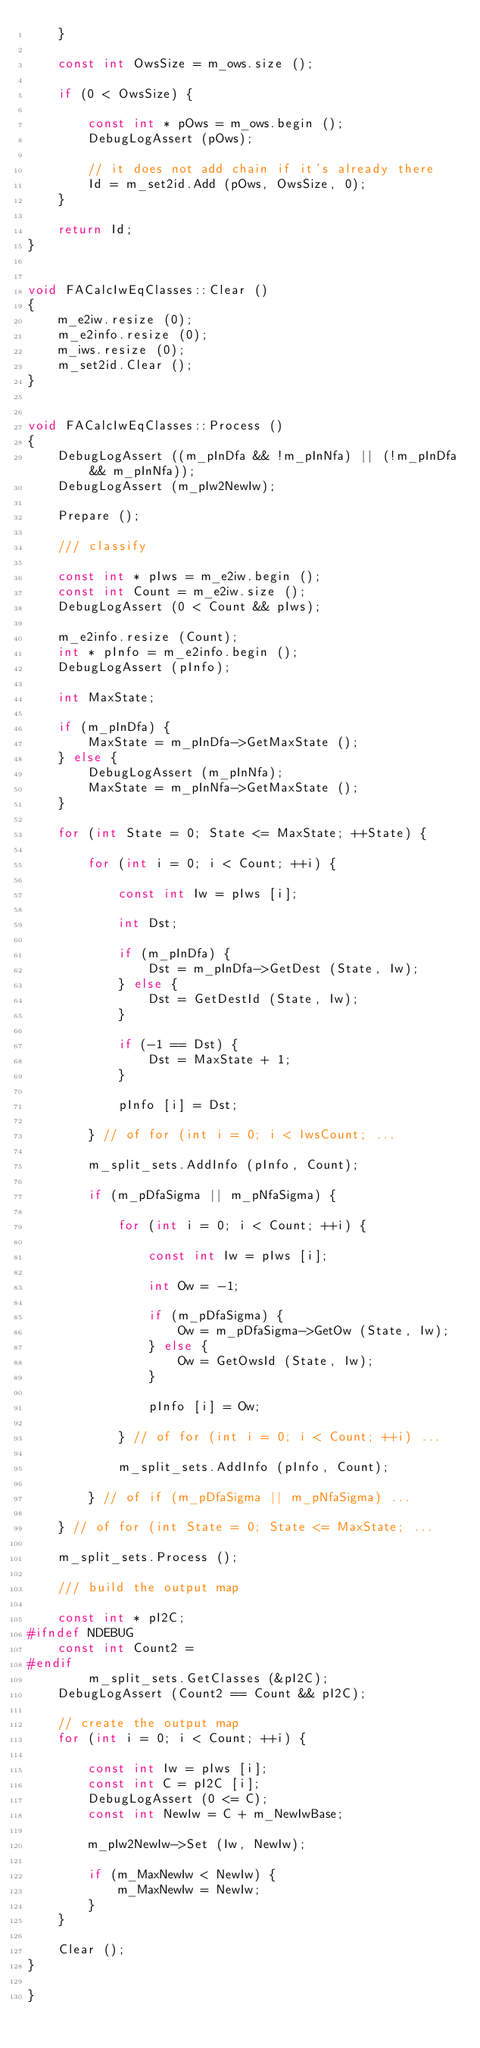<code> <loc_0><loc_0><loc_500><loc_500><_C++_>    }

    const int OwsSize = m_ows.size ();

    if (0 < OwsSize) {

        const int * pOws = m_ows.begin ();
        DebugLogAssert (pOws);

        // it does not add chain if it's already there
        Id = m_set2id.Add (pOws, OwsSize, 0);
    }

    return Id;
}


void FACalcIwEqClasses::Clear ()
{
    m_e2iw.resize (0);
    m_e2info.resize (0);
    m_iws.resize (0);
    m_set2id.Clear ();
}


void FACalcIwEqClasses::Process ()
{
    DebugLogAssert ((m_pInDfa && !m_pInNfa) || (!m_pInDfa && m_pInNfa));
    DebugLogAssert (m_pIw2NewIw);

    Prepare ();

    /// classify

    const int * pIws = m_e2iw.begin ();
    const int Count = m_e2iw.size ();
    DebugLogAssert (0 < Count && pIws);

    m_e2info.resize (Count);
    int * pInfo = m_e2info.begin ();
    DebugLogAssert (pInfo);

    int MaxState;
    
    if (m_pInDfa) {
        MaxState = m_pInDfa->GetMaxState ();
    } else {
        DebugLogAssert (m_pInNfa);
        MaxState = m_pInNfa->GetMaxState ();
    }

    for (int State = 0; State <= MaxState; ++State) {

        for (int i = 0; i < Count; ++i) {

            const int Iw = pIws [i];

            int Dst;

            if (m_pInDfa) {
                Dst = m_pInDfa->GetDest (State, Iw);
            } else {
                Dst = GetDestId (State, Iw);
            }

            if (-1 == Dst) {
                Dst = MaxState + 1;
            }

            pInfo [i] = Dst;

        } // of for (int i = 0; i < IwsCount; ...

        m_split_sets.AddInfo (pInfo, Count);

        if (m_pDfaSigma || m_pNfaSigma) {

            for (int i = 0; i < Count; ++i) {

                const int Iw = pIws [i];

                int Ow = -1;

                if (m_pDfaSigma) {
                    Ow = m_pDfaSigma->GetOw (State, Iw);
                } else {
                    Ow = GetOwsId (State, Iw);
                }

                pInfo [i] = Ow;

            } // of for (int i = 0; i < Count; ++i) ...

            m_split_sets.AddInfo (pInfo, Count);

        } // of if (m_pDfaSigma || m_pNfaSigma) ...

    } // of for (int State = 0; State <= MaxState; ...

    m_split_sets.Process ();

    /// build the output map

    const int * pI2C;
#ifndef NDEBUG
    const int Count2 = 
#endif
        m_split_sets.GetClasses (&pI2C);
    DebugLogAssert (Count2 == Count && pI2C);

    // create the output map
    for (int i = 0; i < Count; ++i) {

        const int Iw = pIws [i];
        const int C = pI2C [i];
        DebugLogAssert (0 <= C);
        const int NewIw = C + m_NewIwBase;

        m_pIw2NewIw->Set (Iw, NewIw);

        if (m_MaxNewIw < NewIw) {
            m_MaxNewIw = NewIw;
        }
    }

    Clear ();
}

}
</code> 